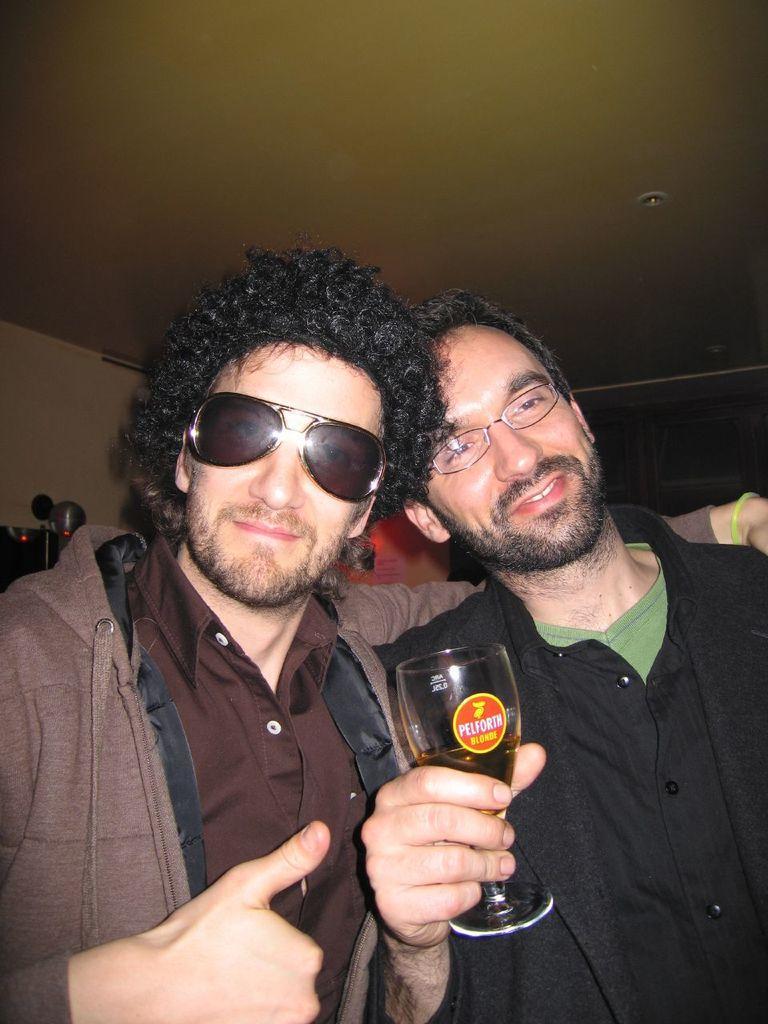Could you give a brief overview of what you see in this image? In this image I can see two persons , they both are wearing spectacles and one person holding glass, at the top there is a roof. 